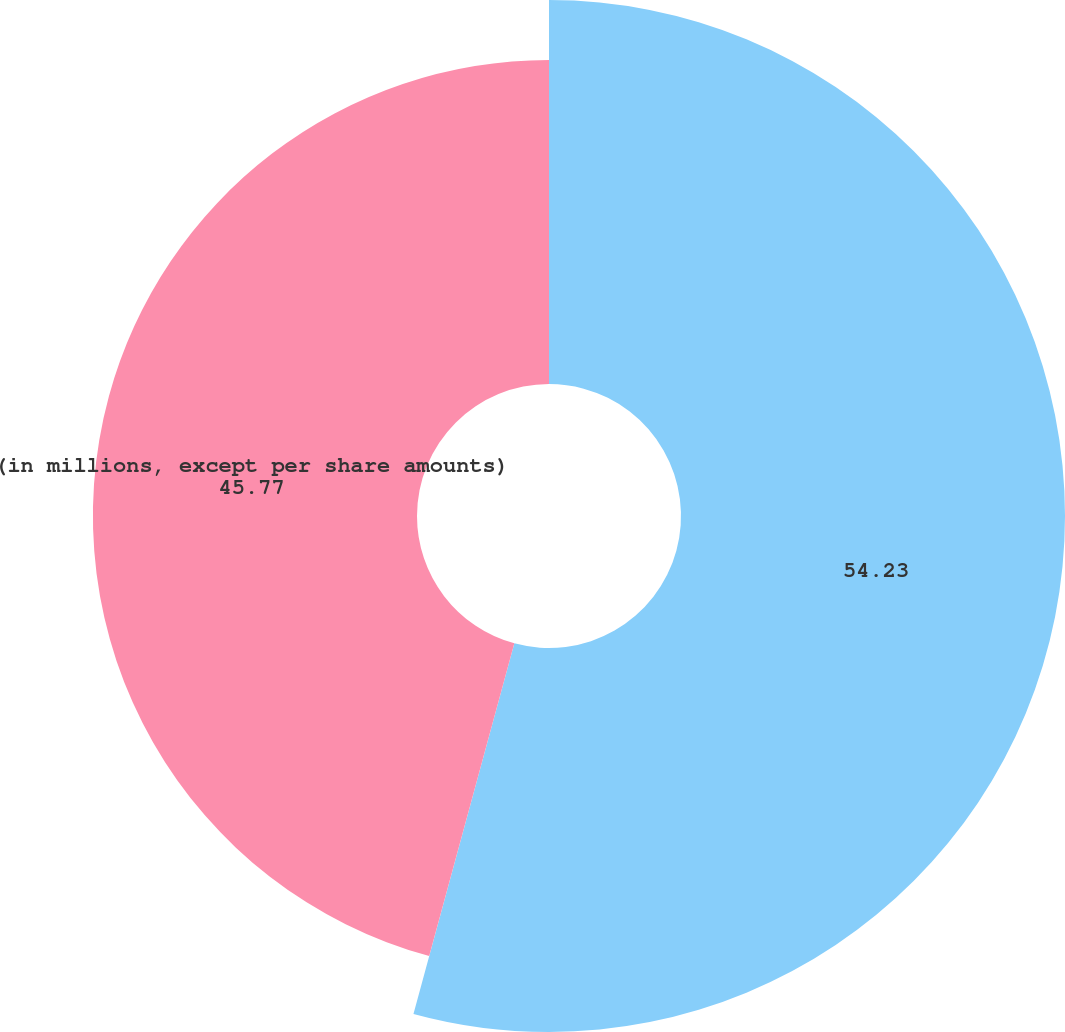Convert chart. <chart><loc_0><loc_0><loc_500><loc_500><pie_chart><ecel><fcel>(in millions, except per share amounts)<nl><fcel>54.23%<fcel>45.77%<nl></chart> 